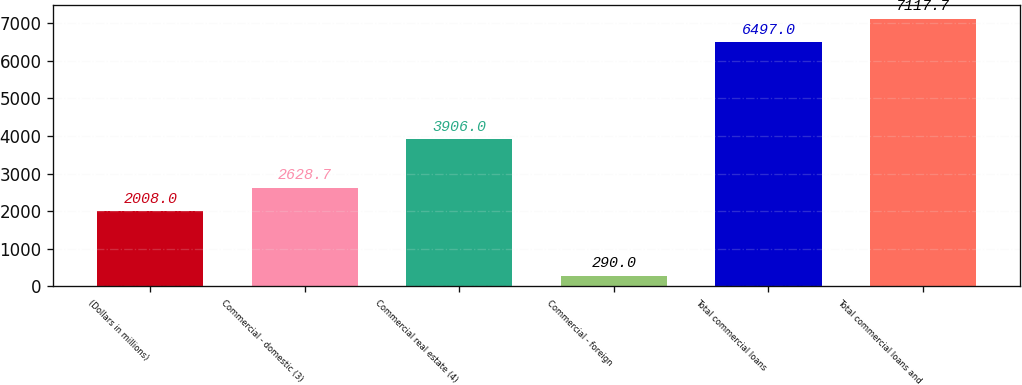<chart> <loc_0><loc_0><loc_500><loc_500><bar_chart><fcel>(Dollars in millions)<fcel>Commercial - domestic (3)<fcel>Commercial real estate (4)<fcel>Commercial - foreign<fcel>Total commercial loans<fcel>Total commercial loans and<nl><fcel>2008<fcel>2628.7<fcel>3906<fcel>290<fcel>6497<fcel>7117.7<nl></chart> 